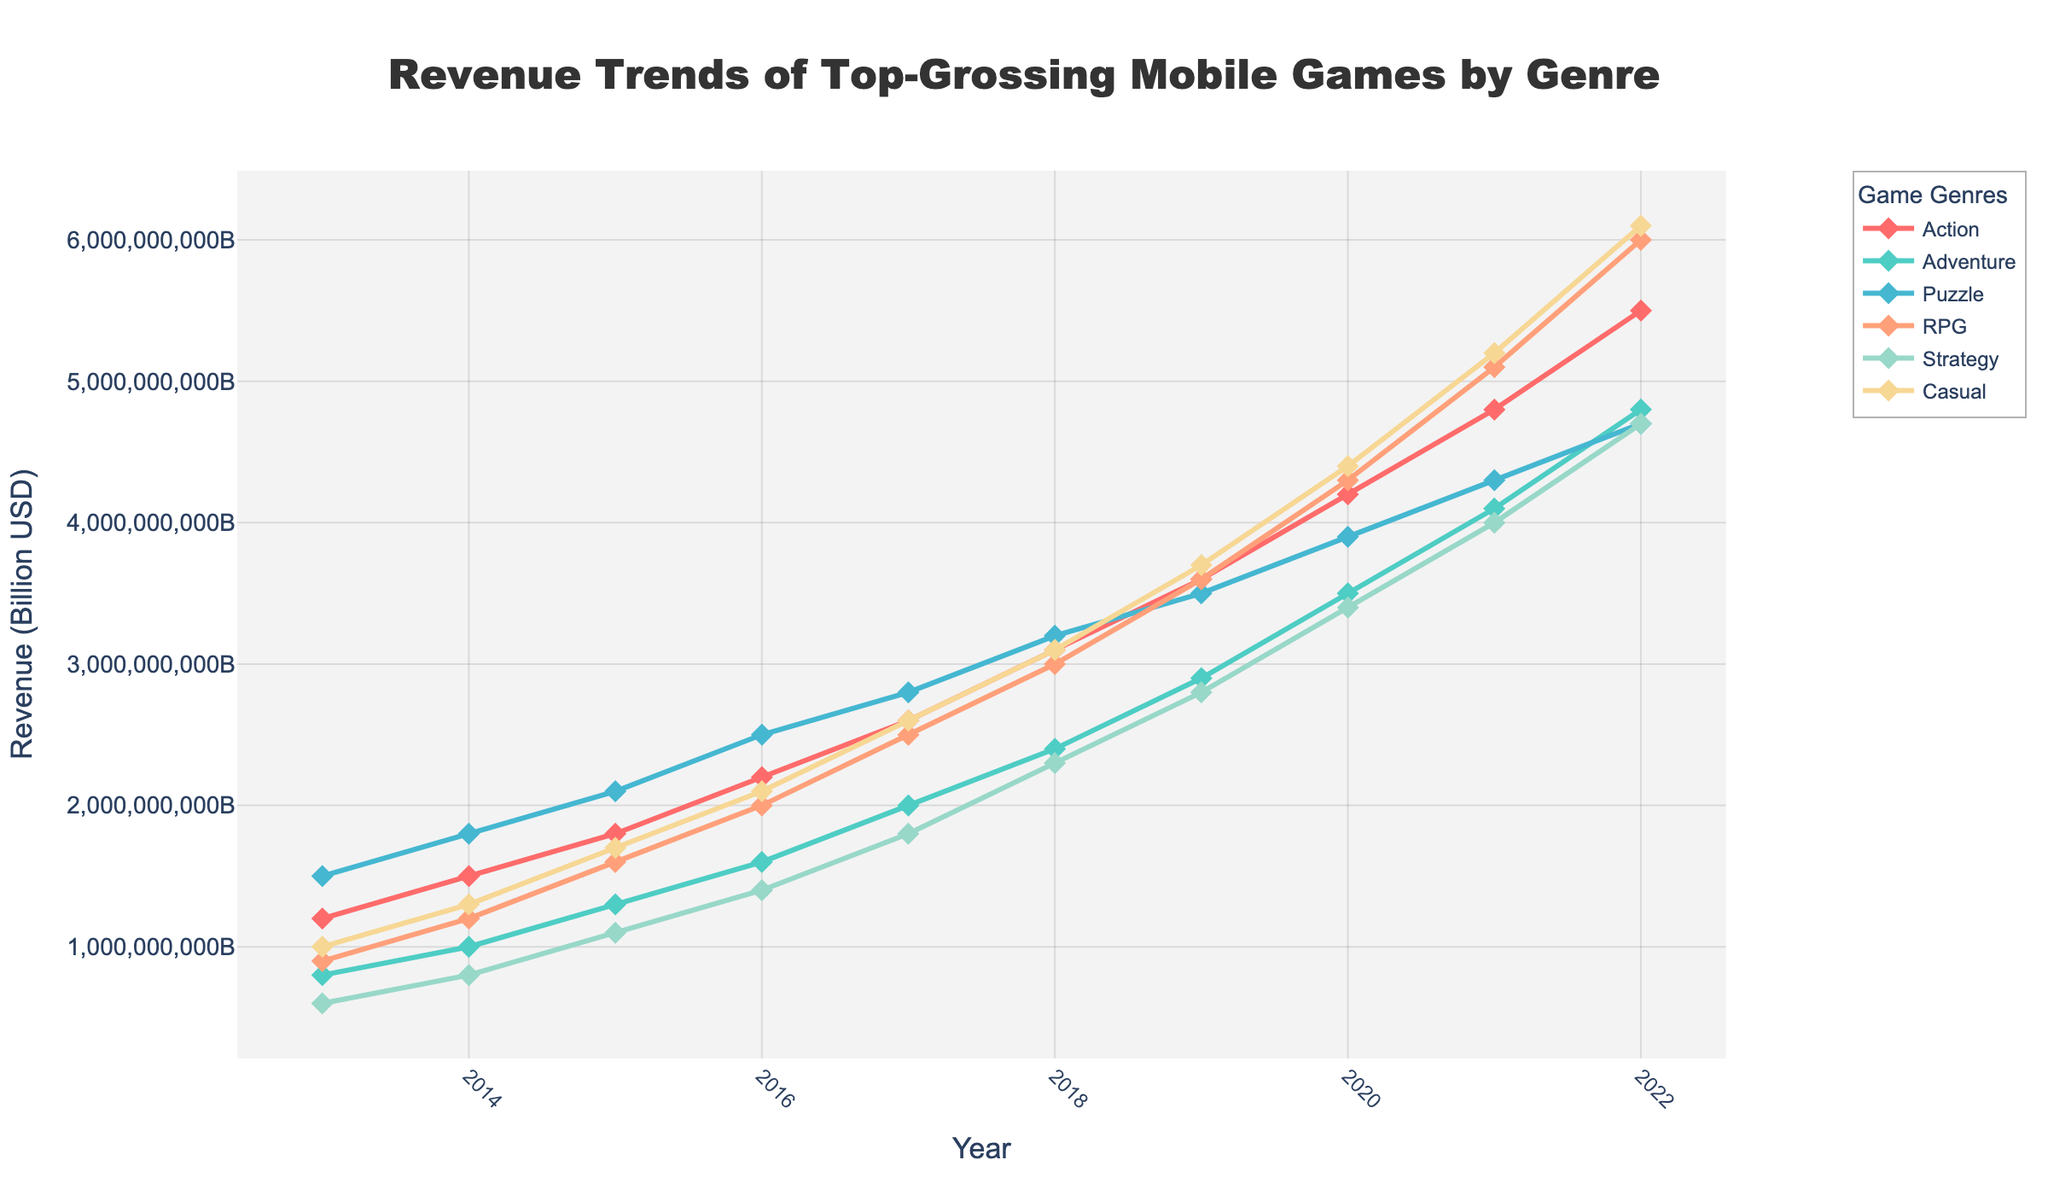which genre has the highest revenue in 2022? The figure indicates the revenue for each genre on the y-axis and the year on the x-axis. For the year 2022, the highest point corresponds to RPG with $6 billion.
Answer: RPG Between 2014 and 2018, by how much did the revenue for the Adventure genre increase? In 2014, Adventure earned $1 billion, and by 2018, it earned $2.4 billion. The increase is $2.4 billion - $1 billion = $1.4 billion.
Answer: $1.4 billion Which genre shows the fastest revenue growth between 2019 and 2022? From the figure, the genre with the steepest incline between 2019 and 2022 is RPG, increasing from $3.6 billion to $6 billion.
Answer: RPG In which year did the Casual genre's revenue surpass $3 billion for the first time? The figure shows that the Casual genre's revenue surpasses the $3 billion mark in 2018.
Answer: 2018 What is the combined revenue for Puzzle and Strategy genres in 2020? Puzzle genre revenue in 2020 is $3.9 billion, and Strategy genre revenue is $3.4 billion. Combined, they sum up to $3.9 billion + $3.4 billion = $7.3 billion.
Answer: $7.3 billion Compare the revenue growth of Action and Puzzle genres from 2015 to 2022. Which genre grew more? Action revenue grew from $1.8 billion in 2015 to $5.5 billion in 2022 (an increase of $3.7 billion). Puzzle revenue grew from $2.1 billion in 2015 to $4.7 billion in 2022 (an increase of $2.6 billion). Therefore, Action grew more.
Answer: Action By how much did the revenue for the Strategy genre increase from 2013 to 2021? In 2013, Strategy revenue was $600 million, and by 2021, it was $4 billion. The increase is $4 billion - $600 million = $3.4 billion.
Answer: $3.4 billion What was the revenue difference between the highest and lowest-grossing genres in 2017? In 2017, RPG was the highest-grossing genre at $2.5 billion, and Strategy was the lowest at $1.8 billion. The difference is $2.5 billion - $1.8 billion = $700 million.
Answer: $700 million 